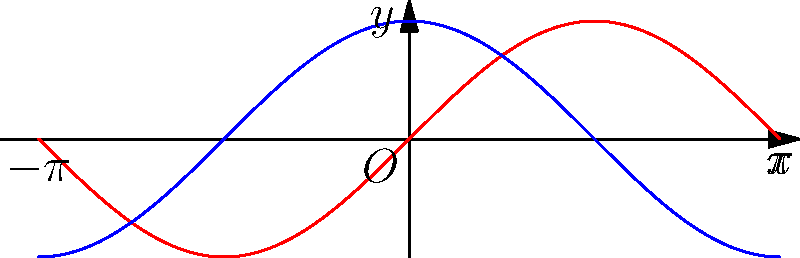In optimizing neural network architectures, we often apply trigonometric transformations to activation functions. Consider a neural network using the sine function as its activation. How would applying a phase shift of $\frac{\pi}{2}$ to this activation function impact the network's behavior, and what would be the resulting function? To solve this problem, let's follow these steps:

1) The original activation function is $f(x) = \sin(x)$.

2) A phase shift of $\frac{\pi}{2}$ in trigonometry is represented by subtracting this value from the function's input:

   $f(x - \frac{\pi}{2})$

3) Let's apply this transformation to our sine function:

   $\sin(x - \frac{\pi}{2})$

4) In trigonometry, there's an identity that states:

   $\sin(A - \frac{\pi}{2}) = -\cos(A)$

5) Applying this identity to our function:

   $\sin(x - \frac{\pi}{2}) = -\cos(x)$

6) Therefore, the resulting function after the phase shift is $-\cos(x)$.

7) In terms of impact on the neural network:
   - The periodicity of the function remains the same (2π)
   - The range remains [-1, 1]
   - However, the behavior changes significantly:
     - Where sine was zero, cosine reaches its extrema
     - Where sine reached its extrema, cosine is zero
   - This could potentially help the network capture different features or relationships in the data
Answer: $-\cos(x)$ 